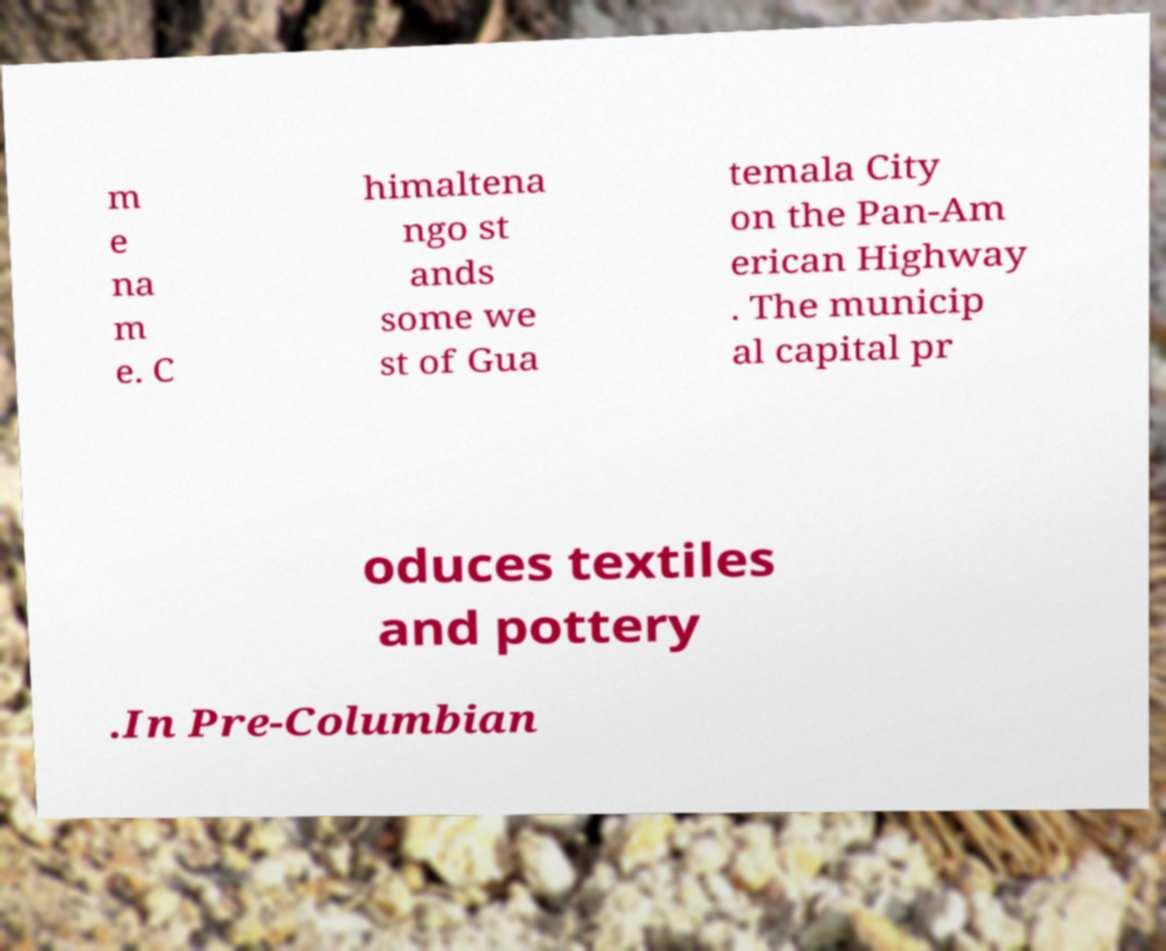There's text embedded in this image that I need extracted. Can you transcribe it verbatim? m e na m e. C himaltena ngo st ands some we st of Gua temala City on the Pan-Am erican Highway . The municip al capital pr oduces textiles and pottery .In Pre-Columbian 